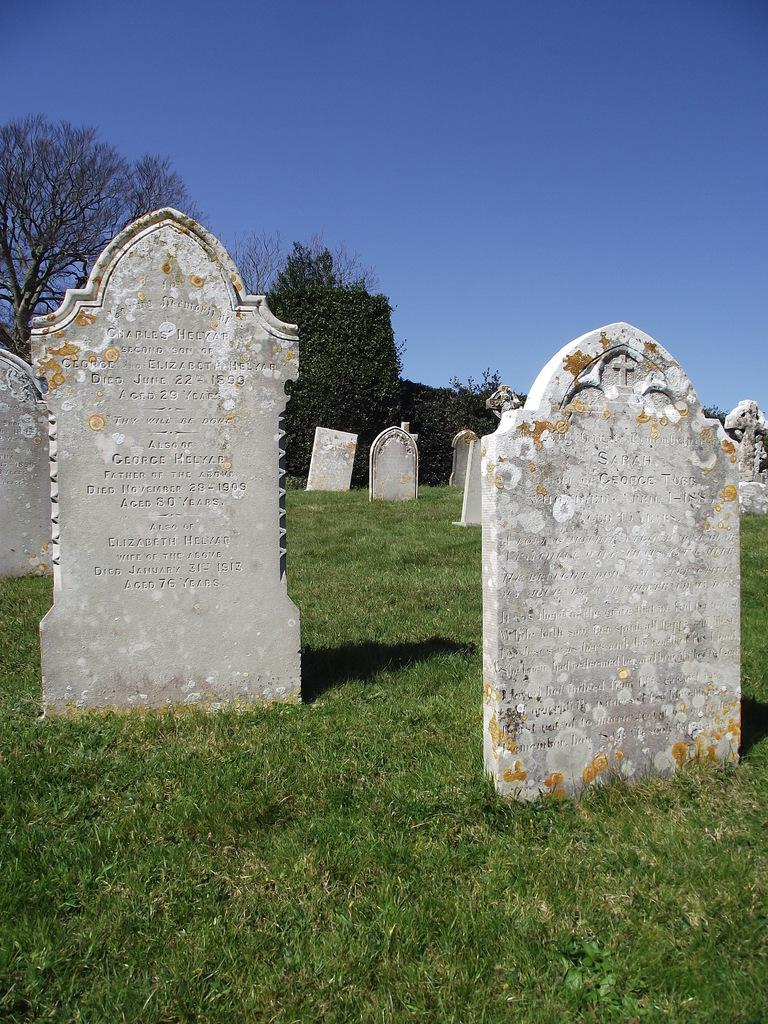What type of location is depicted in the image? The image depicts a graveyard. What can be seen on the ground in the graveyard? There is grass on the ground. What is visible in the background of the image? There are trees and the sky visible in the background of the image. What type of cracker is being used to surprise the ducks at the dock in the image? There is no dock, ducks, or crackers present in the image. The image depicts a graveyard with grass, trees, and the sky visible in the background. 